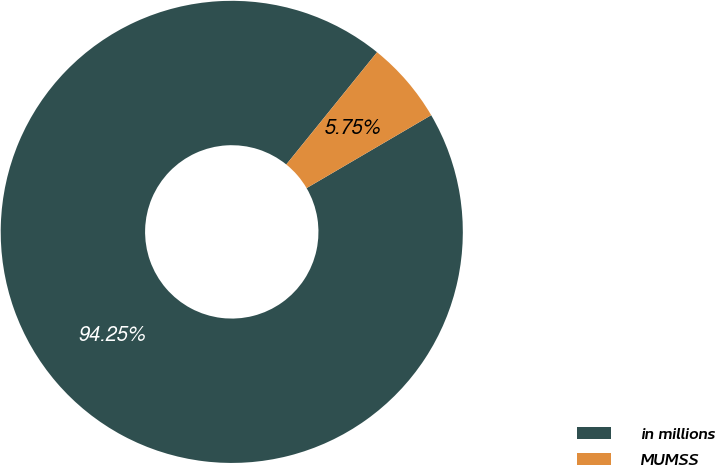Convert chart. <chart><loc_0><loc_0><loc_500><loc_500><pie_chart><fcel>in millions<fcel>MUMSS<nl><fcel>94.25%<fcel>5.75%<nl></chart> 